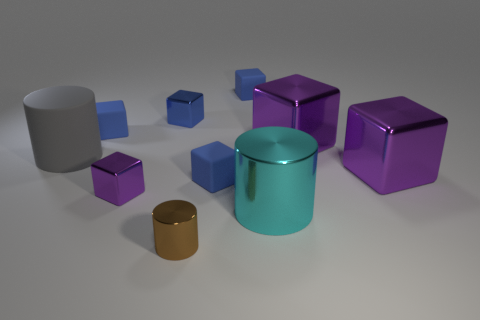Is the material of the large cylinder that is left of the cyan metal cylinder the same as the tiny blue thing that is in front of the gray matte thing?
Provide a short and direct response. Yes. How many matte things are tiny blue objects or big gray blocks?
Offer a terse response. 3. There is a tiny thing in front of the large cylinder that is in front of the purple metal thing that is to the left of the brown thing; what is its material?
Provide a succinct answer. Metal. Is the shape of the purple shiny object that is behind the gray rubber cylinder the same as the gray rubber thing behind the brown object?
Make the answer very short. No. There is a large block in front of the big cylinder that is on the left side of the blue metallic object; what is its color?
Make the answer very short. Purple. What number of blocks are small brown things or tiny gray matte objects?
Make the answer very short. 0. There is a small metal object behind the blue matte block on the left side of the blue shiny block; how many brown metal cylinders are in front of it?
Keep it short and to the point. 1. Are there any small purple objects that have the same material as the cyan cylinder?
Your answer should be compact. Yes. Is the brown cylinder made of the same material as the large cyan cylinder?
Make the answer very short. Yes. How many big purple metal cubes are to the right of the cylinder that is in front of the cyan metal object?
Offer a terse response. 2. 